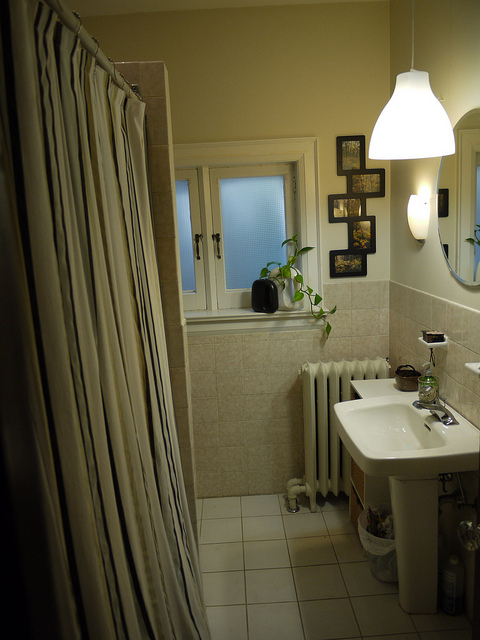<image>What kind of window treatments are shown? I am not sure about the window treatments shown. It can be normal, shutter, inswing windows, or tempered glass. However, it may not be presented at all. Is it sunny day? I can't confirm if it's a sunny day as it could be either yes or no. Are the doors open? I don't know if the doors are open. It can be both open and closed. Are the doors open? The doors are closed. Is it sunny day? I am not sure if it is a sunny day or not. It can be both sunny or not sunny. What kind of window treatments are shown? I don't know what kind of window treatments are shown. It can be 'none', 'closed', 'shutter', 'inswing windows' or 'tempered glass'. 